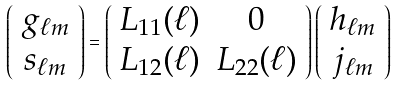Convert formula to latex. <formula><loc_0><loc_0><loc_500><loc_500>\left ( \begin{array} { c } g _ { \ell m } \\ s _ { \ell m } \\ \end{array} \right ) = \left ( \begin{array} { c c } L _ { 1 1 } ( \ell ) & 0 \\ L _ { 1 2 } ( \ell ) & L _ { 2 2 } ( \ell ) \\ \end{array} \right ) \left ( \begin{array} { c } h _ { \ell m } \\ j _ { \ell m } \\ \end{array} \right )</formula> 